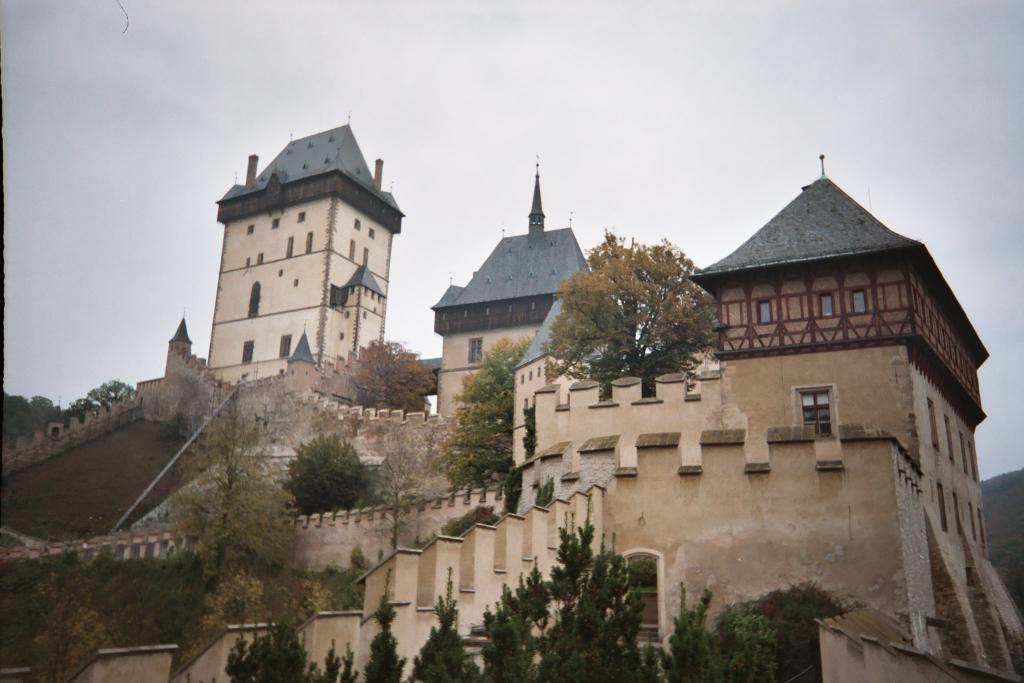What is the main subject in the center of the image? There is a building in the center of the image. What type of natural elements can be seen in the image? There are trees in the image. What is visible at the top of the image? The sky is visible at the top of the image. What type of rice is being cooked in the building in the image? There is no indication of rice or cooking in the image; it features a building, trees, and the sky. 